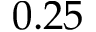Convert formula to latex. <formula><loc_0><loc_0><loc_500><loc_500>0 . 2 5</formula> 